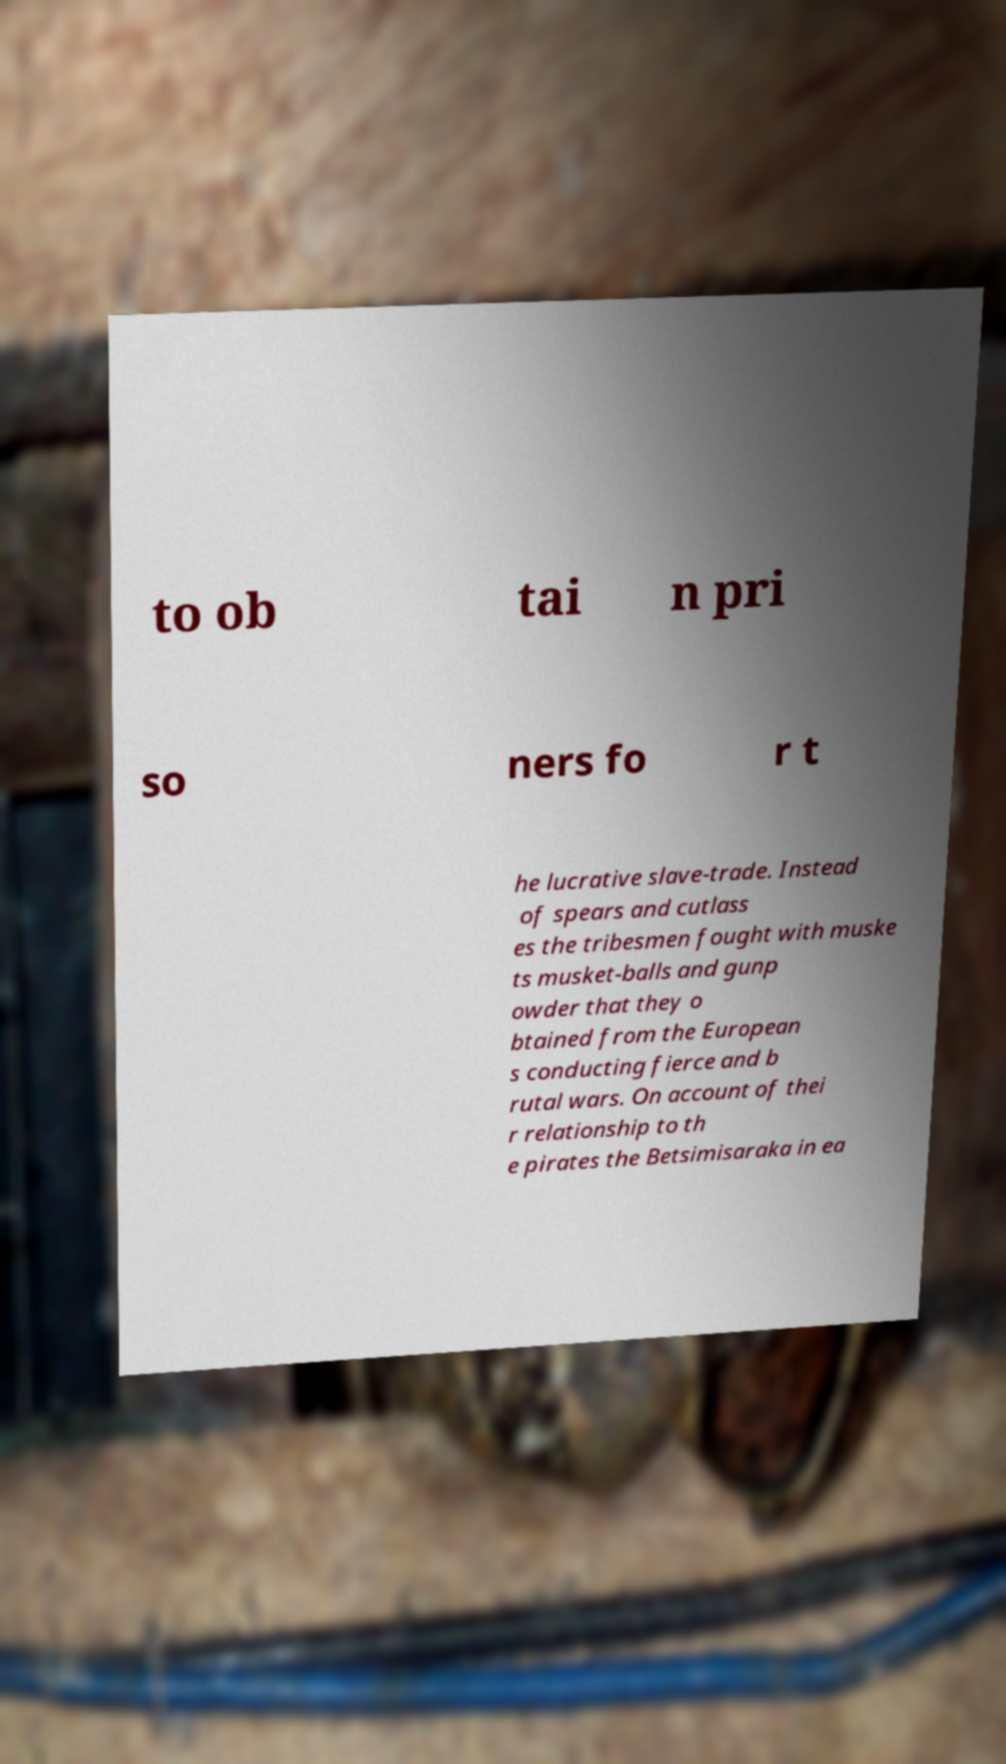What messages or text are displayed in this image? I need them in a readable, typed format. to ob tai n pri so ners fo r t he lucrative slave-trade. Instead of spears and cutlass es the tribesmen fought with muske ts musket-balls and gunp owder that they o btained from the European s conducting fierce and b rutal wars. On account of thei r relationship to th e pirates the Betsimisaraka in ea 